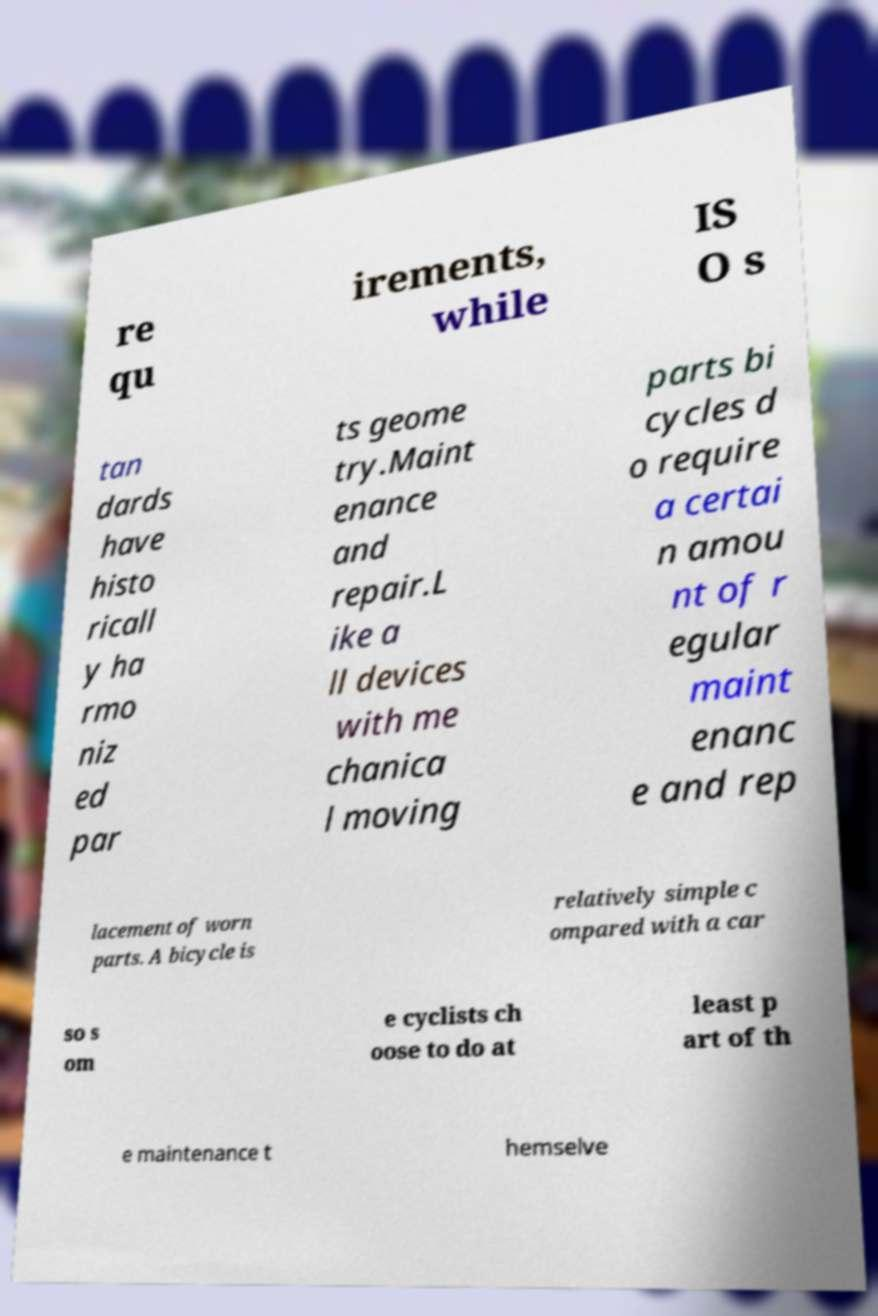Could you extract and type out the text from this image? re qu irements, while IS O s tan dards have histo ricall y ha rmo niz ed par ts geome try.Maint enance and repair.L ike a ll devices with me chanica l moving parts bi cycles d o require a certai n amou nt of r egular maint enanc e and rep lacement of worn parts. A bicycle is relatively simple c ompared with a car so s om e cyclists ch oose to do at least p art of th e maintenance t hemselve 